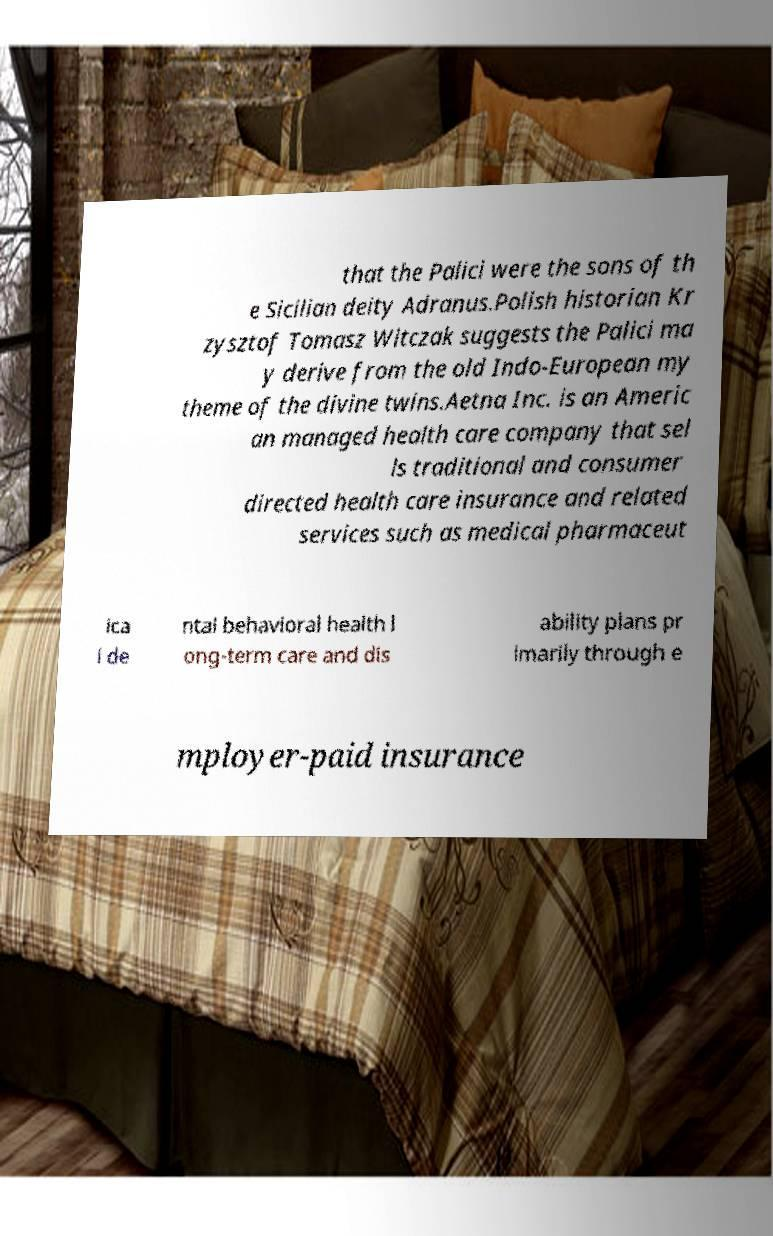Could you extract and type out the text from this image? that the Palici were the sons of th e Sicilian deity Adranus.Polish historian Kr zysztof Tomasz Witczak suggests the Palici ma y derive from the old Indo-European my theme of the divine twins.Aetna Inc. is an Americ an managed health care company that sel ls traditional and consumer directed health care insurance and related services such as medical pharmaceut ica l de ntal behavioral health l ong-term care and dis ability plans pr imarily through e mployer-paid insurance 